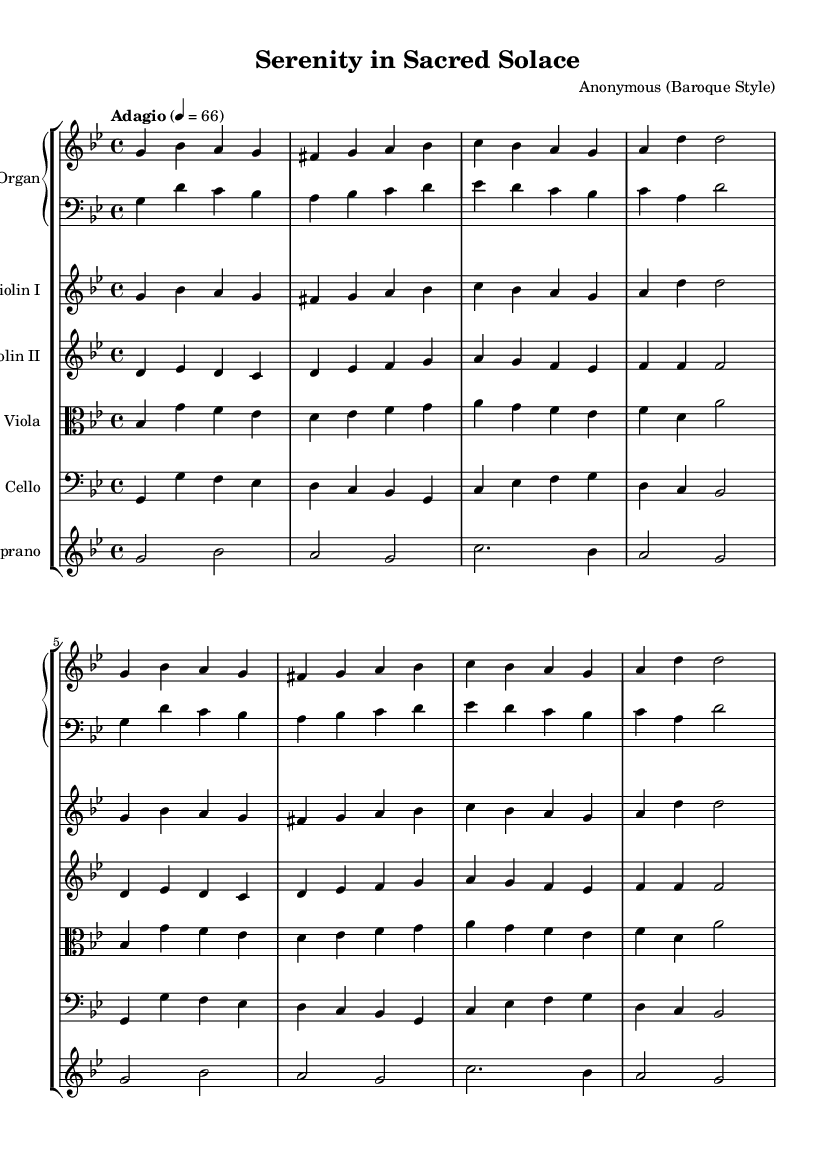What is the key signature of this music? The key signature is indicated at the beginning of the music and shows two flats (B♭ and E♭), which means it is in G minor.
Answer: G minor What is the time signature of this music? The time signature is shown at the beginning of the music, specifically written as 4 over 4, indicating four beats per measure.
Answer: 4/4 What is the tempo marking of this piece? The tempo marking, indicated above the staff, reads "Adagio" followed by the note value indicating a speed of 66 beats per minute.
Answer: Adagio, 66 How many measures are there in the "Organ" part? By counting the measures in both the upper and lower parts of the Organ staff, there are 8 measures in total.
Answer: 8 What instruments are included in this composition? The instruments are listed at the beginning and include Organ, Violin I, Violin II, Viola, Cello, and Soprano.
Answer: Organ, Violin I, Violin II, Viola, Cello, Soprano What is the final note for the Soprano part? By examining the last measure of the Soprano staff, the final note is A.
Answer: A What style of music is this composition? The title indicates that it is "Baroque Style," which is characterized by its ornate musical features and expressiveness typical of the Baroque period.
Answer: Baroque 